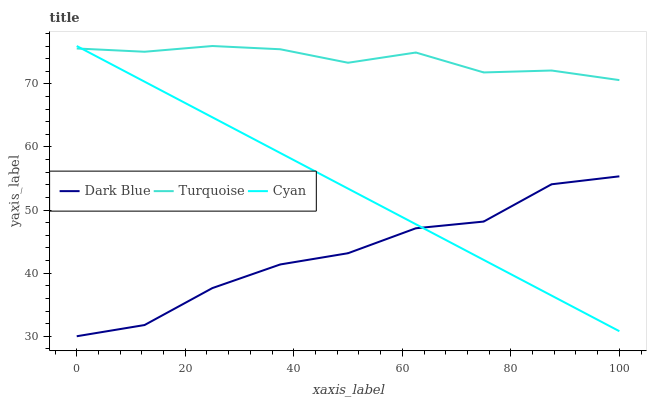Does Cyan have the minimum area under the curve?
Answer yes or no. No. Does Cyan have the maximum area under the curve?
Answer yes or no. No. Is Turquoise the smoothest?
Answer yes or no. No. Is Turquoise the roughest?
Answer yes or no. No. Does Cyan have the lowest value?
Answer yes or no. No. Is Dark Blue less than Turquoise?
Answer yes or no. Yes. Is Turquoise greater than Dark Blue?
Answer yes or no. Yes. Does Dark Blue intersect Turquoise?
Answer yes or no. No. 